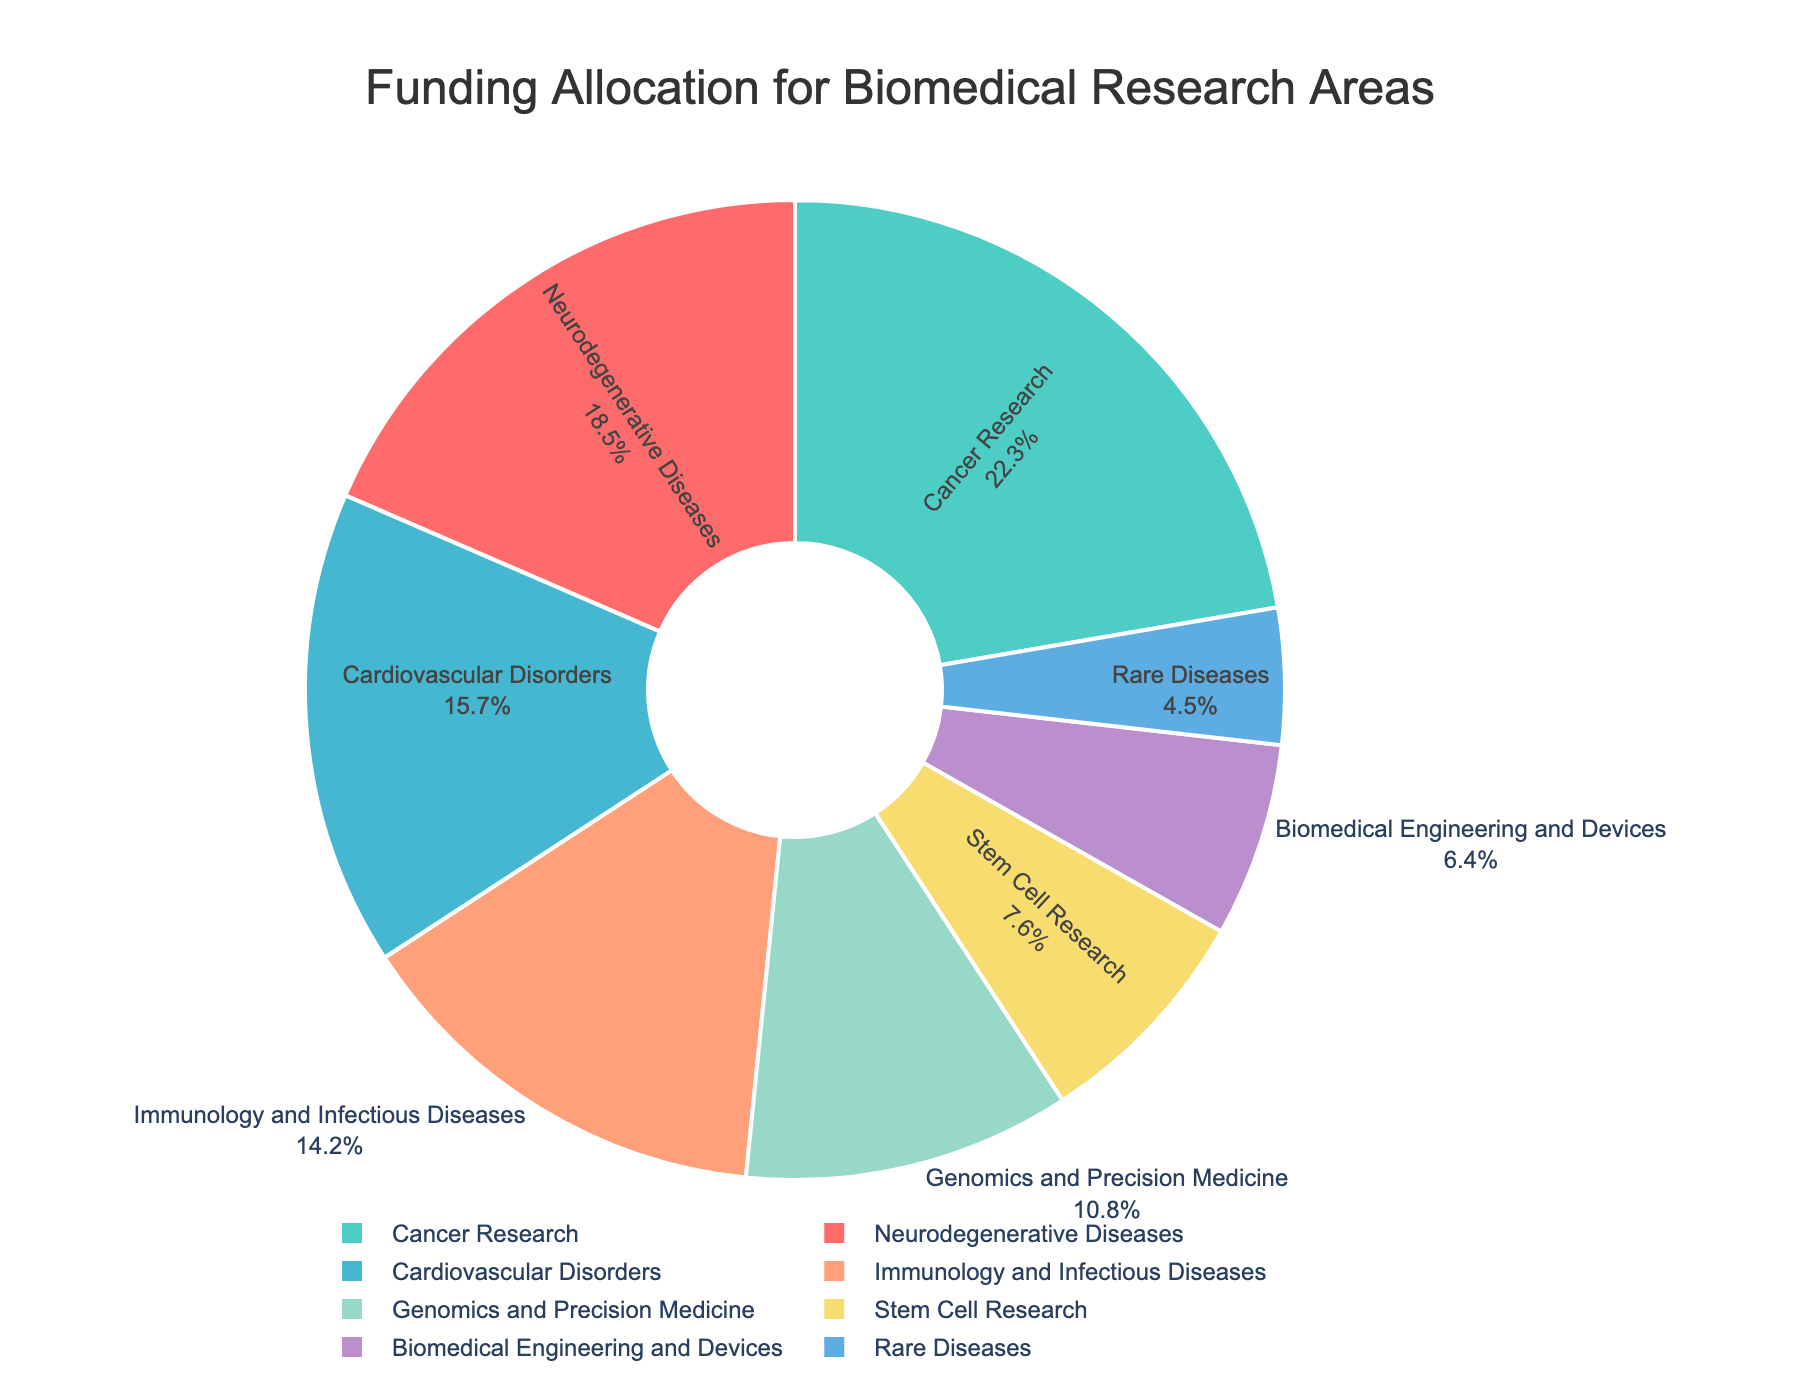What's the area with the highest funding allocation? The area with the highest funding will have the largest slice in the pie chart and the highest percentage label. According to the data, Cancer Research has the highest funding allocation at 22.3%.
Answer: Cancer Research What's the total funding percentage allocated to Neurodegenerative Diseases and Cardiovascular Disorders combined? To find this, we add the funding percentages for Neurodegenerative Diseases (18.5%) and Cardiovascular Disorders (15.7%). The total is 18.5% + 15.7% = 34.2%.
Answer: 34.2% Which area has a smaller funding allocation: Genomics and Precision Medicine or Rare Diseases? By comparing their percentages on the pie chart, we see that Genomics and Precision Medicine is allocated 10.8%, and Rare Diseases is allocated 4.5%. Rare Diseases has a smaller funding allocation.
Answer: Rare Diseases How much more funding percentage is allocated to Immunology and Infectious Diseases than to Stem Cell Research? To find the difference, subtract the funding percentage of Stem Cell Research (7.6%) from Immunology and Infectious Diseases (14.2%). The difference is 14.2% - 7.6% = 6.6%.
Answer: 6.6% What is the combined funding percentage for Biomedical Engineering and Devices, and Rare Diseases? Add the funding percentages for Biomedical Engineering and Devices (6.4%) and Rare Diseases (4.5%). The combined funding is 6.4% + 4.5% = 10.9%.
Answer: 10.9% What percentage more funding does Cancer Research receive compared to Stem Cell Research? Subtract the funding percentage of Stem Cell Research (7.6%) from Cancer Research (22.3%). The difference is 22.3% - 7.6% = 14.7%.
Answer: 14.7% Which section of the pie chart is colored red and what's the funding percentage? By looking at the visual where the red color is used, it corresponds to the largest slice which is Cancer Research. Therefore, Cancer Research has a funding percentage of 22.3%.
Answer: Cancer Research, 22.3% 